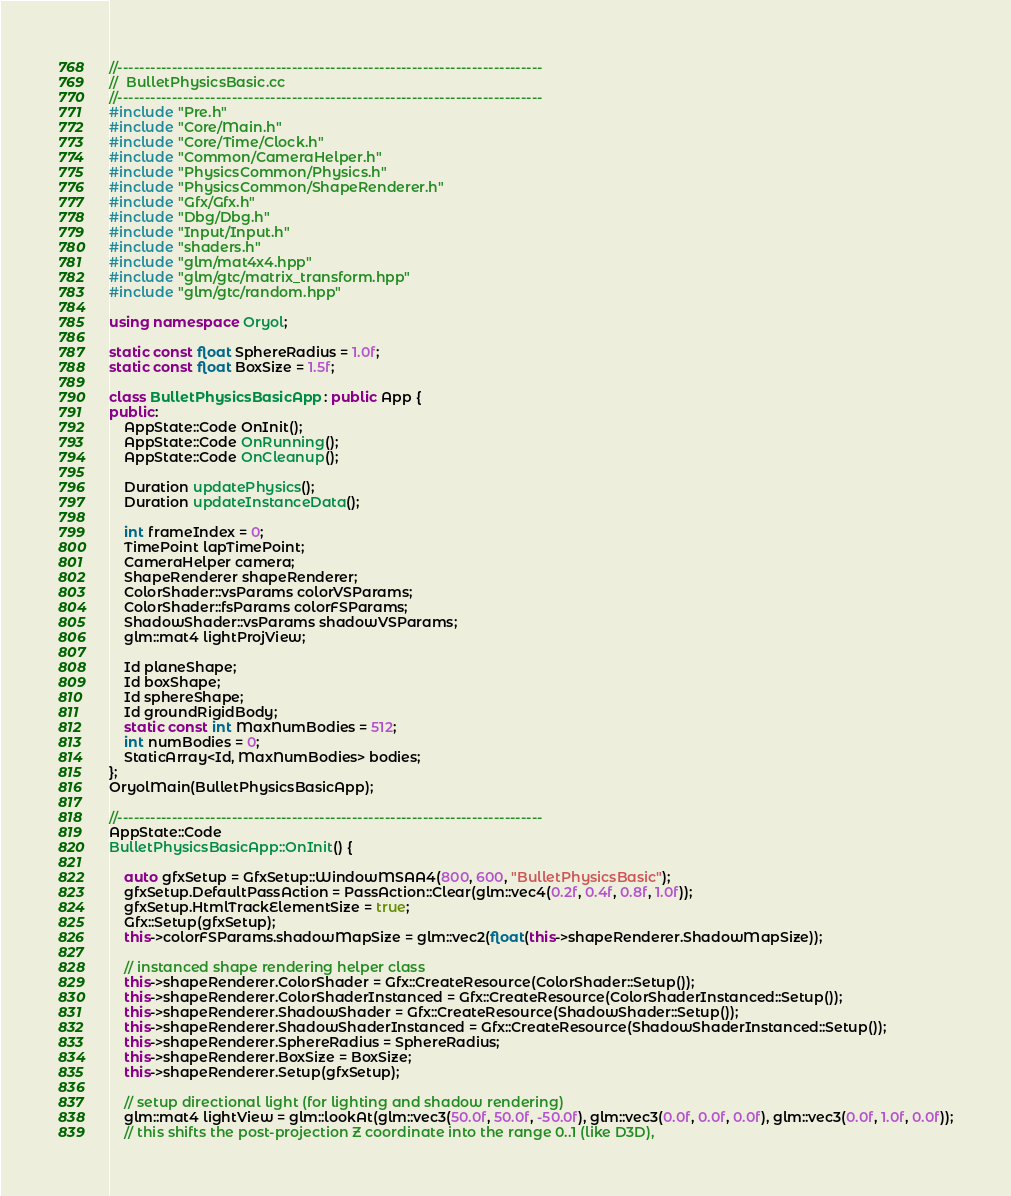<code> <loc_0><loc_0><loc_500><loc_500><_C++_>//------------------------------------------------------------------------------
//  BulletPhysicsBasic.cc
//------------------------------------------------------------------------------
#include "Pre.h"
#include "Core/Main.h"
#include "Core/Time/Clock.h"
#include "Common/CameraHelper.h"
#include "PhysicsCommon/Physics.h"
#include "PhysicsCommon/ShapeRenderer.h"
#include "Gfx/Gfx.h"
#include "Dbg/Dbg.h"
#include "Input/Input.h"
#include "shaders.h"
#include "glm/mat4x4.hpp"
#include "glm/gtc/matrix_transform.hpp"
#include "glm/gtc/random.hpp"

using namespace Oryol;

static const float SphereRadius = 1.0f;
static const float BoxSize = 1.5f;

class BulletPhysicsBasicApp : public App {
public:
    AppState::Code OnInit();
    AppState::Code OnRunning();
    AppState::Code OnCleanup();

    Duration updatePhysics();
    Duration updateInstanceData();

    int frameIndex = 0;
    TimePoint lapTimePoint;
    CameraHelper camera;
    ShapeRenderer shapeRenderer;
    ColorShader::vsParams colorVSParams;
    ColorShader::fsParams colorFSParams;
    ShadowShader::vsParams shadowVSParams;
    glm::mat4 lightProjView;

    Id planeShape;
    Id boxShape;
    Id sphereShape;
    Id groundRigidBody;
    static const int MaxNumBodies = 512;
    int numBodies = 0;
    StaticArray<Id, MaxNumBodies> bodies;
};
OryolMain(BulletPhysicsBasicApp);

//------------------------------------------------------------------------------
AppState::Code
BulletPhysicsBasicApp::OnInit() {

    auto gfxSetup = GfxSetup::WindowMSAA4(800, 600, "BulletPhysicsBasic");
    gfxSetup.DefaultPassAction = PassAction::Clear(glm::vec4(0.2f, 0.4f, 0.8f, 1.0f));
    gfxSetup.HtmlTrackElementSize = true;
    Gfx::Setup(gfxSetup);
    this->colorFSParams.shadowMapSize = glm::vec2(float(this->shapeRenderer.ShadowMapSize));

    // instanced shape rendering helper class
    this->shapeRenderer.ColorShader = Gfx::CreateResource(ColorShader::Setup());
    this->shapeRenderer.ColorShaderInstanced = Gfx::CreateResource(ColorShaderInstanced::Setup());
    this->shapeRenderer.ShadowShader = Gfx::CreateResource(ShadowShader::Setup());
    this->shapeRenderer.ShadowShaderInstanced = Gfx::CreateResource(ShadowShaderInstanced::Setup());
    this->shapeRenderer.SphereRadius = SphereRadius;
    this->shapeRenderer.BoxSize = BoxSize;
    this->shapeRenderer.Setup(gfxSetup);

    // setup directional light (for lighting and shadow rendering)
    glm::mat4 lightView = glm::lookAt(glm::vec3(50.0f, 50.0f, -50.0f), glm::vec3(0.0f, 0.0f, 0.0f), glm::vec3(0.0f, 1.0f, 0.0f));
    // this shifts the post-projection Z coordinate into the range 0..1 (like D3D), </code> 